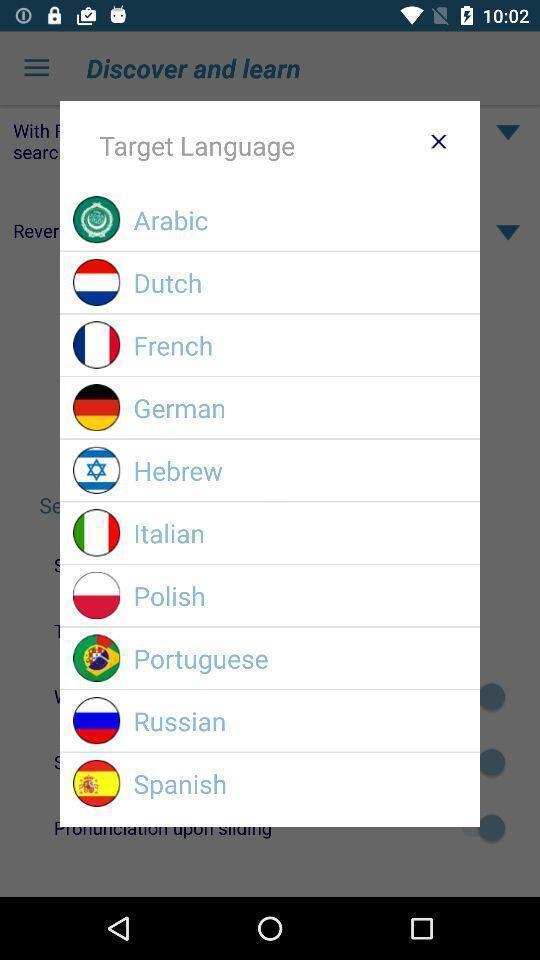Tell me about the visual elements in this screen capture. Popup showing about different language. 